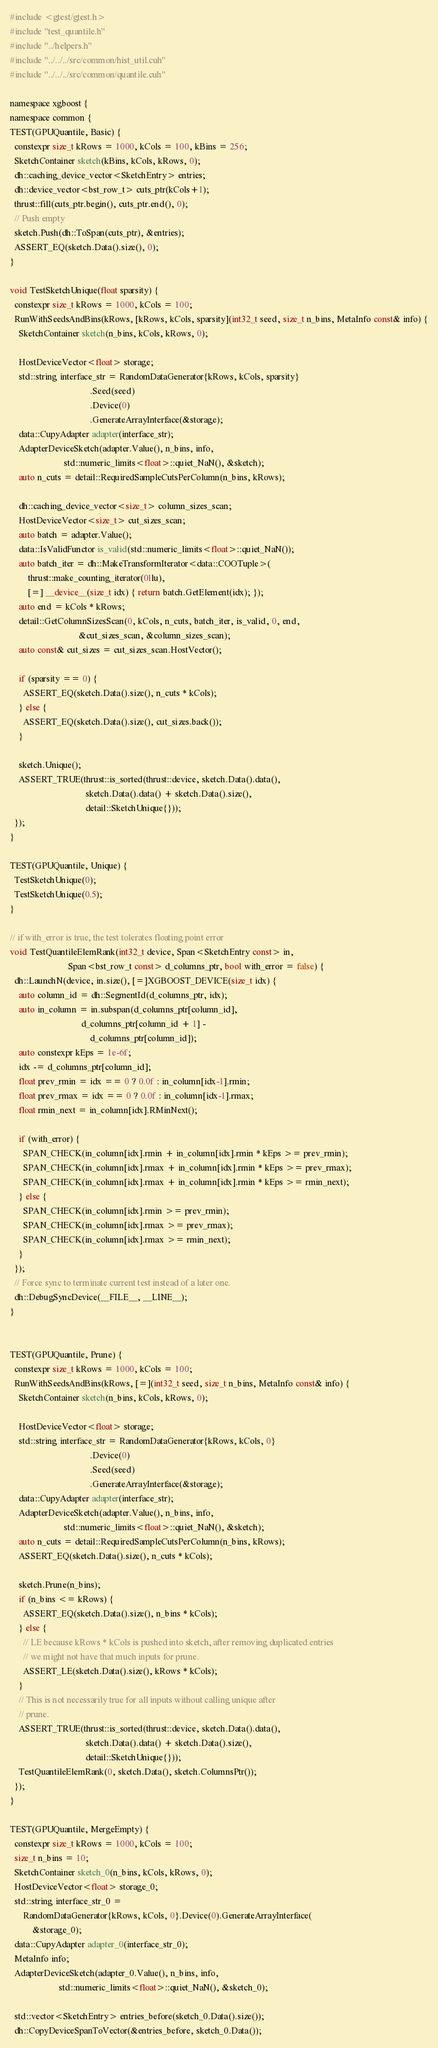Convert code to text. <code><loc_0><loc_0><loc_500><loc_500><_Cuda_>#include <gtest/gtest.h>
#include "test_quantile.h"
#include "../helpers.h"
#include "../../../src/common/hist_util.cuh"
#include "../../../src/common/quantile.cuh"

namespace xgboost {
namespace common {
TEST(GPUQuantile, Basic) {
  constexpr size_t kRows = 1000, kCols = 100, kBins = 256;
  SketchContainer sketch(kBins, kCols, kRows, 0);
  dh::caching_device_vector<SketchEntry> entries;
  dh::device_vector<bst_row_t> cuts_ptr(kCols+1);
  thrust::fill(cuts_ptr.begin(), cuts_ptr.end(), 0);
  // Push empty
  sketch.Push(dh::ToSpan(cuts_ptr), &entries);
  ASSERT_EQ(sketch.Data().size(), 0);
}

void TestSketchUnique(float sparsity) {
  constexpr size_t kRows = 1000, kCols = 100;
  RunWithSeedsAndBins(kRows, [kRows, kCols, sparsity](int32_t seed, size_t n_bins, MetaInfo const& info) {
    SketchContainer sketch(n_bins, kCols, kRows, 0);

    HostDeviceVector<float> storage;
    std::string interface_str = RandomDataGenerator{kRows, kCols, sparsity}
                                    .Seed(seed)
                                    .Device(0)
                                    .GenerateArrayInterface(&storage);
    data::CupyAdapter adapter(interface_str);
    AdapterDeviceSketch(adapter.Value(), n_bins, info,
                        std::numeric_limits<float>::quiet_NaN(), &sketch);
    auto n_cuts = detail::RequiredSampleCutsPerColumn(n_bins, kRows);

    dh::caching_device_vector<size_t> column_sizes_scan;
    HostDeviceVector<size_t> cut_sizes_scan;
    auto batch = adapter.Value();
    data::IsValidFunctor is_valid(std::numeric_limits<float>::quiet_NaN());
    auto batch_iter = dh::MakeTransformIterator<data::COOTuple>(
        thrust::make_counting_iterator(0llu),
        [=] __device__(size_t idx) { return batch.GetElement(idx); });
    auto end = kCols * kRows;
    detail::GetColumnSizesScan(0, kCols, n_cuts, batch_iter, is_valid, 0, end,
                               &cut_sizes_scan, &column_sizes_scan);
    auto const& cut_sizes = cut_sizes_scan.HostVector();

    if (sparsity == 0) {
      ASSERT_EQ(sketch.Data().size(), n_cuts * kCols);
    } else {
      ASSERT_EQ(sketch.Data().size(), cut_sizes.back());
    }

    sketch.Unique();
    ASSERT_TRUE(thrust::is_sorted(thrust::device, sketch.Data().data(),
                                  sketch.Data().data() + sketch.Data().size(),
                                  detail::SketchUnique{}));
  });
}

TEST(GPUQuantile, Unique) {
  TestSketchUnique(0);
  TestSketchUnique(0.5);
}

// if with_error is true, the test tolerates floating point error
void TestQuantileElemRank(int32_t device, Span<SketchEntry const> in,
                          Span<bst_row_t const> d_columns_ptr, bool with_error = false) {
  dh::LaunchN(device, in.size(), [=]XGBOOST_DEVICE(size_t idx) {
    auto column_id = dh::SegmentId(d_columns_ptr, idx);
    auto in_column = in.subspan(d_columns_ptr[column_id],
                                d_columns_ptr[column_id + 1] -
                                    d_columns_ptr[column_id]);
    auto constexpr kEps = 1e-6f;
    idx -= d_columns_ptr[column_id];
    float prev_rmin = idx == 0 ? 0.0f : in_column[idx-1].rmin;
    float prev_rmax = idx == 0 ? 0.0f : in_column[idx-1].rmax;
    float rmin_next = in_column[idx].RMinNext();

    if (with_error) {
      SPAN_CHECK(in_column[idx].rmin + in_column[idx].rmin * kEps >= prev_rmin);
      SPAN_CHECK(in_column[idx].rmax + in_column[idx].rmin * kEps >= prev_rmax);
      SPAN_CHECK(in_column[idx].rmax + in_column[idx].rmin * kEps >= rmin_next);
    } else {
      SPAN_CHECK(in_column[idx].rmin >= prev_rmin);
      SPAN_CHECK(in_column[idx].rmax >= prev_rmax);
      SPAN_CHECK(in_column[idx].rmax >= rmin_next);
    }
  });
  // Force sync to terminate current test instead of a later one.
  dh::DebugSyncDevice(__FILE__, __LINE__);
}


TEST(GPUQuantile, Prune) {
  constexpr size_t kRows = 1000, kCols = 100;
  RunWithSeedsAndBins(kRows, [=](int32_t seed, size_t n_bins, MetaInfo const& info) {
    SketchContainer sketch(n_bins, kCols, kRows, 0);

    HostDeviceVector<float> storage;
    std::string interface_str = RandomDataGenerator{kRows, kCols, 0}
                                    .Device(0)
                                    .Seed(seed)
                                    .GenerateArrayInterface(&storage);
    data::CupyAdapter adapter(interface_str);
    AdapterDeviceSketch(adapter.Value(), n_bins, info,
                        std::numeric_limits<float>::quiet_NaN(), &sketch);
    auto n_cuts = detail::RequiredSampleCutsPerColumn(n_bins, kRows);
    ASSERT_EQ(sketch.Data().size(), n_cuts * kCols);

    sketch.Prune(n_bins);
    if (n_bins <= kRows) {
      ASSERT_EQ(sketch.Data().size(), n_bins * kCols);
    } else {
      // LE because kRows * kCols is pushed into sketch, after removing duplicated entries
      // we might not have that much inputs for prune.
      ASSERT_LE(sketch.Data().size(), kRows * kCols);
    }
    // This is not necessarily true for all inputs without calling unique after
    // prune.
    ASSERT_TRUE(thrust::is_sorted(thrust::device, sketch.Data().data(),
                                  sketch.Data().data() + sketch.Data().size(),
                                  detail::SketchUnique{}));
    TestQuantileElemRank(0, sketch.Data(), sketch.ColumnsPtr());
  });
}

TEST(GPUQuantile, MergeEmpty) {
  constexpr size_t kRows = 1000, kCols = 100;
  size_t n_bins = 10;
  SketchContainer sketch_0(n_bins, kCols, kRows, 0);
  HostDeviceVector<float> storage_0;
  std::string interface_str_0 =
      RandomDataGenerator{kRows, kCols, 0}.Device(0).GenerateArrayInterface(
          &storage_0);
  data::CupyAdapter adapter_0(interface_str_0);
  MetaInfo info;
  AdapterDeviceSketch(adapter_0.Value(), n_bins, info,
                      std::numeric_limits<float>::quiet_NaN(), &sketch_0);

  std::vector<SketchEntry> entries_before(sketch_0.Data().size());
  dh::CopyDeviceSpanToVector(&entries_before, sketch_0.Data());</code> 